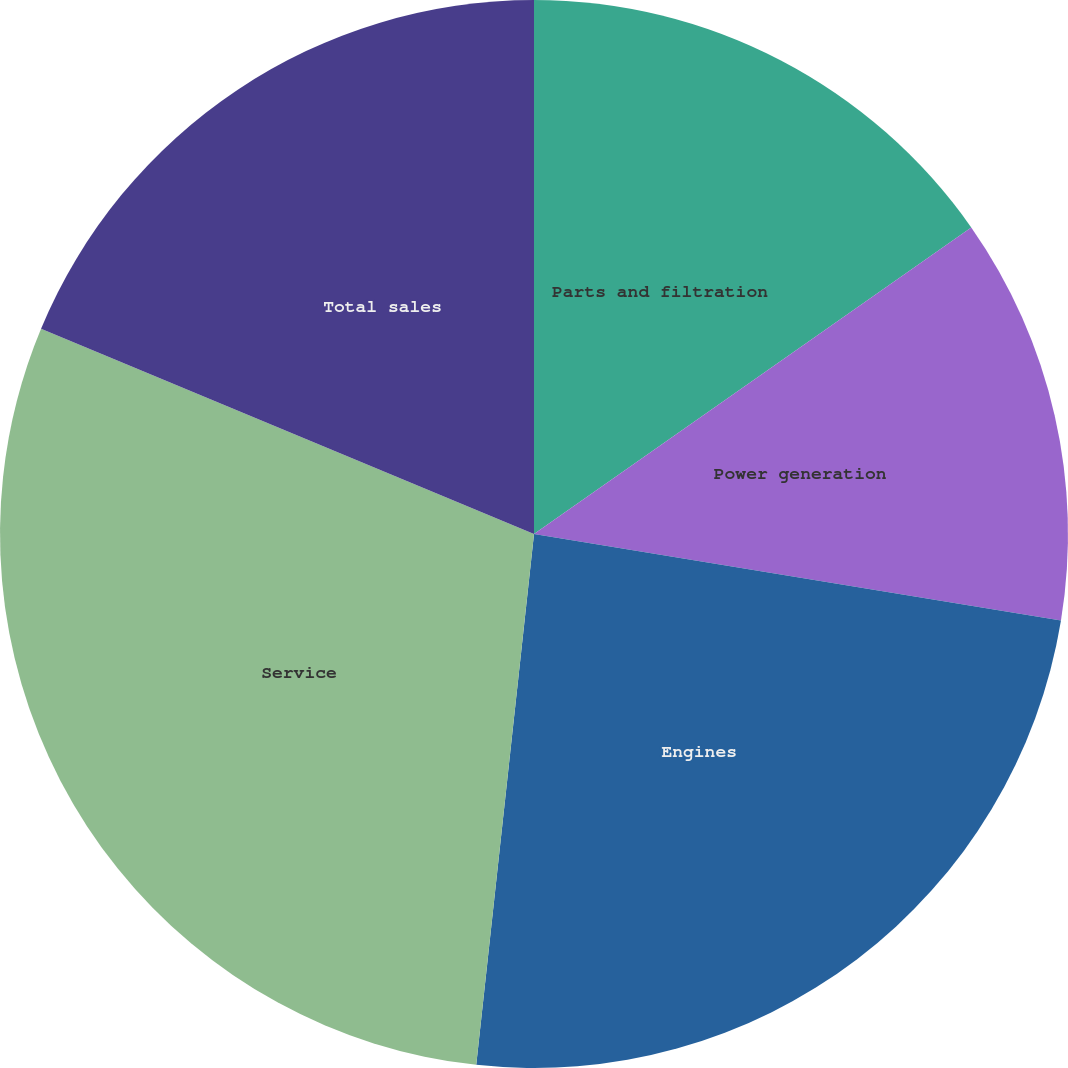Convert chart. <chart><loc_0><loc_0><loc_500><loc_500><pie_chart><fcel>Parts and filtration<fcel>Power generation<fcel>Engines<fcel>Service<fcel>Total sales<nl><fcel>15.27%<fcel>12.32%<fcel>24.14%<fcel>29.56%<fcel>18.72%<nl></chart> 